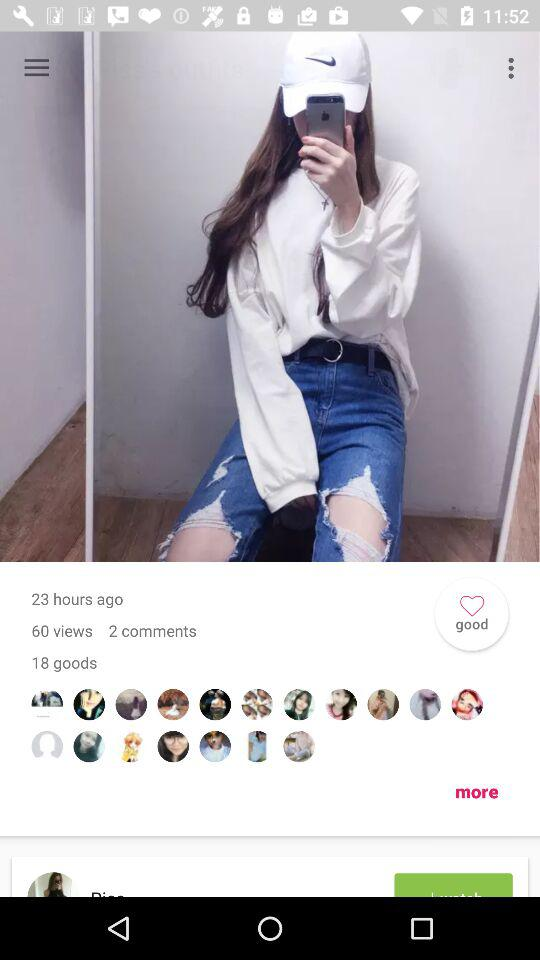How many comments are there on the photo? There are 2 comments. 